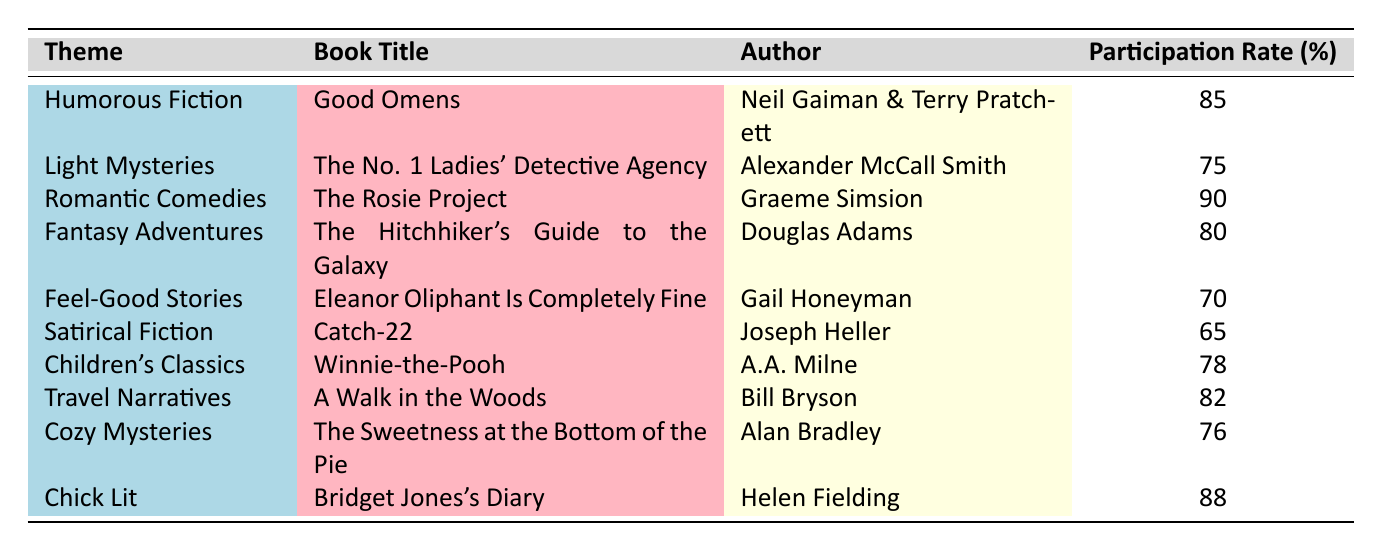What is the participation rate for Romantic Comedies? The table indicates that the participation rate for the theme "Romantic Comedies" is listed next to the book title "The Rosie Project," which has a participation rate of 90%.
Answer: 90 Which theme has the lowest participation rate? By comparing the participation rates listed, "Satirical Fiction" has the lowest participation rate of 65%, as no other theme is below this rate.
Answer: 65 Is the participation rate for "Children's Classics" higher than 75%? The participation rate for "Children's Classics," which corresponds to the title "Winnie-the-Pooh," is 78%. Since 78% is greater than 75%, the answer is yes.
Answer: Yes What is the average participation rate of the themes related to mystery genres? We find the participation rates for the themes related to mysteries: "Light Mysteries" (75%), "Cozy Mysteries" (76%), and "Satirical Fiction" (65%). We sum up these rates: 75 + 76 + 65 = 216, and then divide by the number of themes which is 3. So the average is 216/3 = 72.
Answer: 72 How many themes have a participation rate of 80% or higher? The themes with participation rates of 80% or higher are "Romantic Comedies" (90%), "Humorous Fiction" (85%), "Chick Lit" (88%), "Travel Narratives" (82%), and "Fantasy Adventures" (80%). This totals 5 themes.
Answer: 5 Which book corresponds to the theme with the highest participation rate? The theme with the highest participation rate is "Romantic Comedies," corresponding to the book "The Rosie Project," which has a participation rate of 90%.
Answer: The Rosie Project Is there a theme related to travel narratives in the list? The table includes "Travel Narratives" as one of the themes, along with its corresponding book title "A Walk in the Woods," confirming that this theme is present.
Answer: Yes What is the total participation rate for all listed themes? To calculate the total participation rate, we must sum the individual participation rates: 85 + 75 + 90 + 80 + 70 + 65 + 78 + 82 + 76 + 88 =  819.
Answer: 819 How does the participation rate for "Cozy Mysteries" compare to that of "Humorous Fiction"? The participation rate for "Cozy Mysteries" is 76%, whereas "Humorous Fiction" has a higher participation rate of 85%. Therefore, "Humorous Fiction" is higher than "Cozy Mysteries."
Answer: Higher 